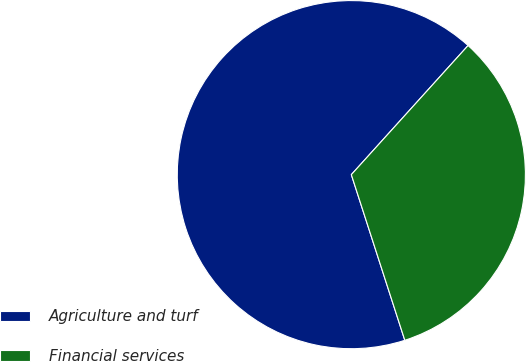Convert chart to OTSL. <chart><loc_0><loc_0><loc_500><loc_500><pie_chart><fcel>Agriculture and turf<fcel>Financial services<nl><fcel>66.67%<fcel>33.33%<nl></chart> 